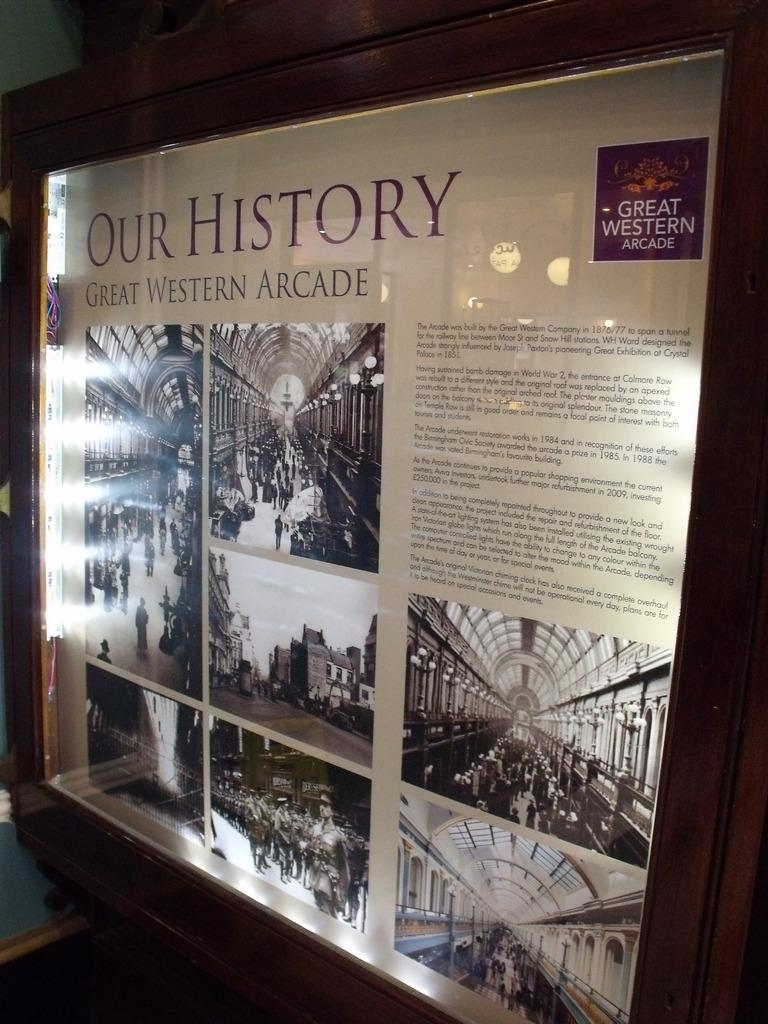<image>
Present a compact description of the photo's key features. A poster describing Our History Great Western Arcade. 